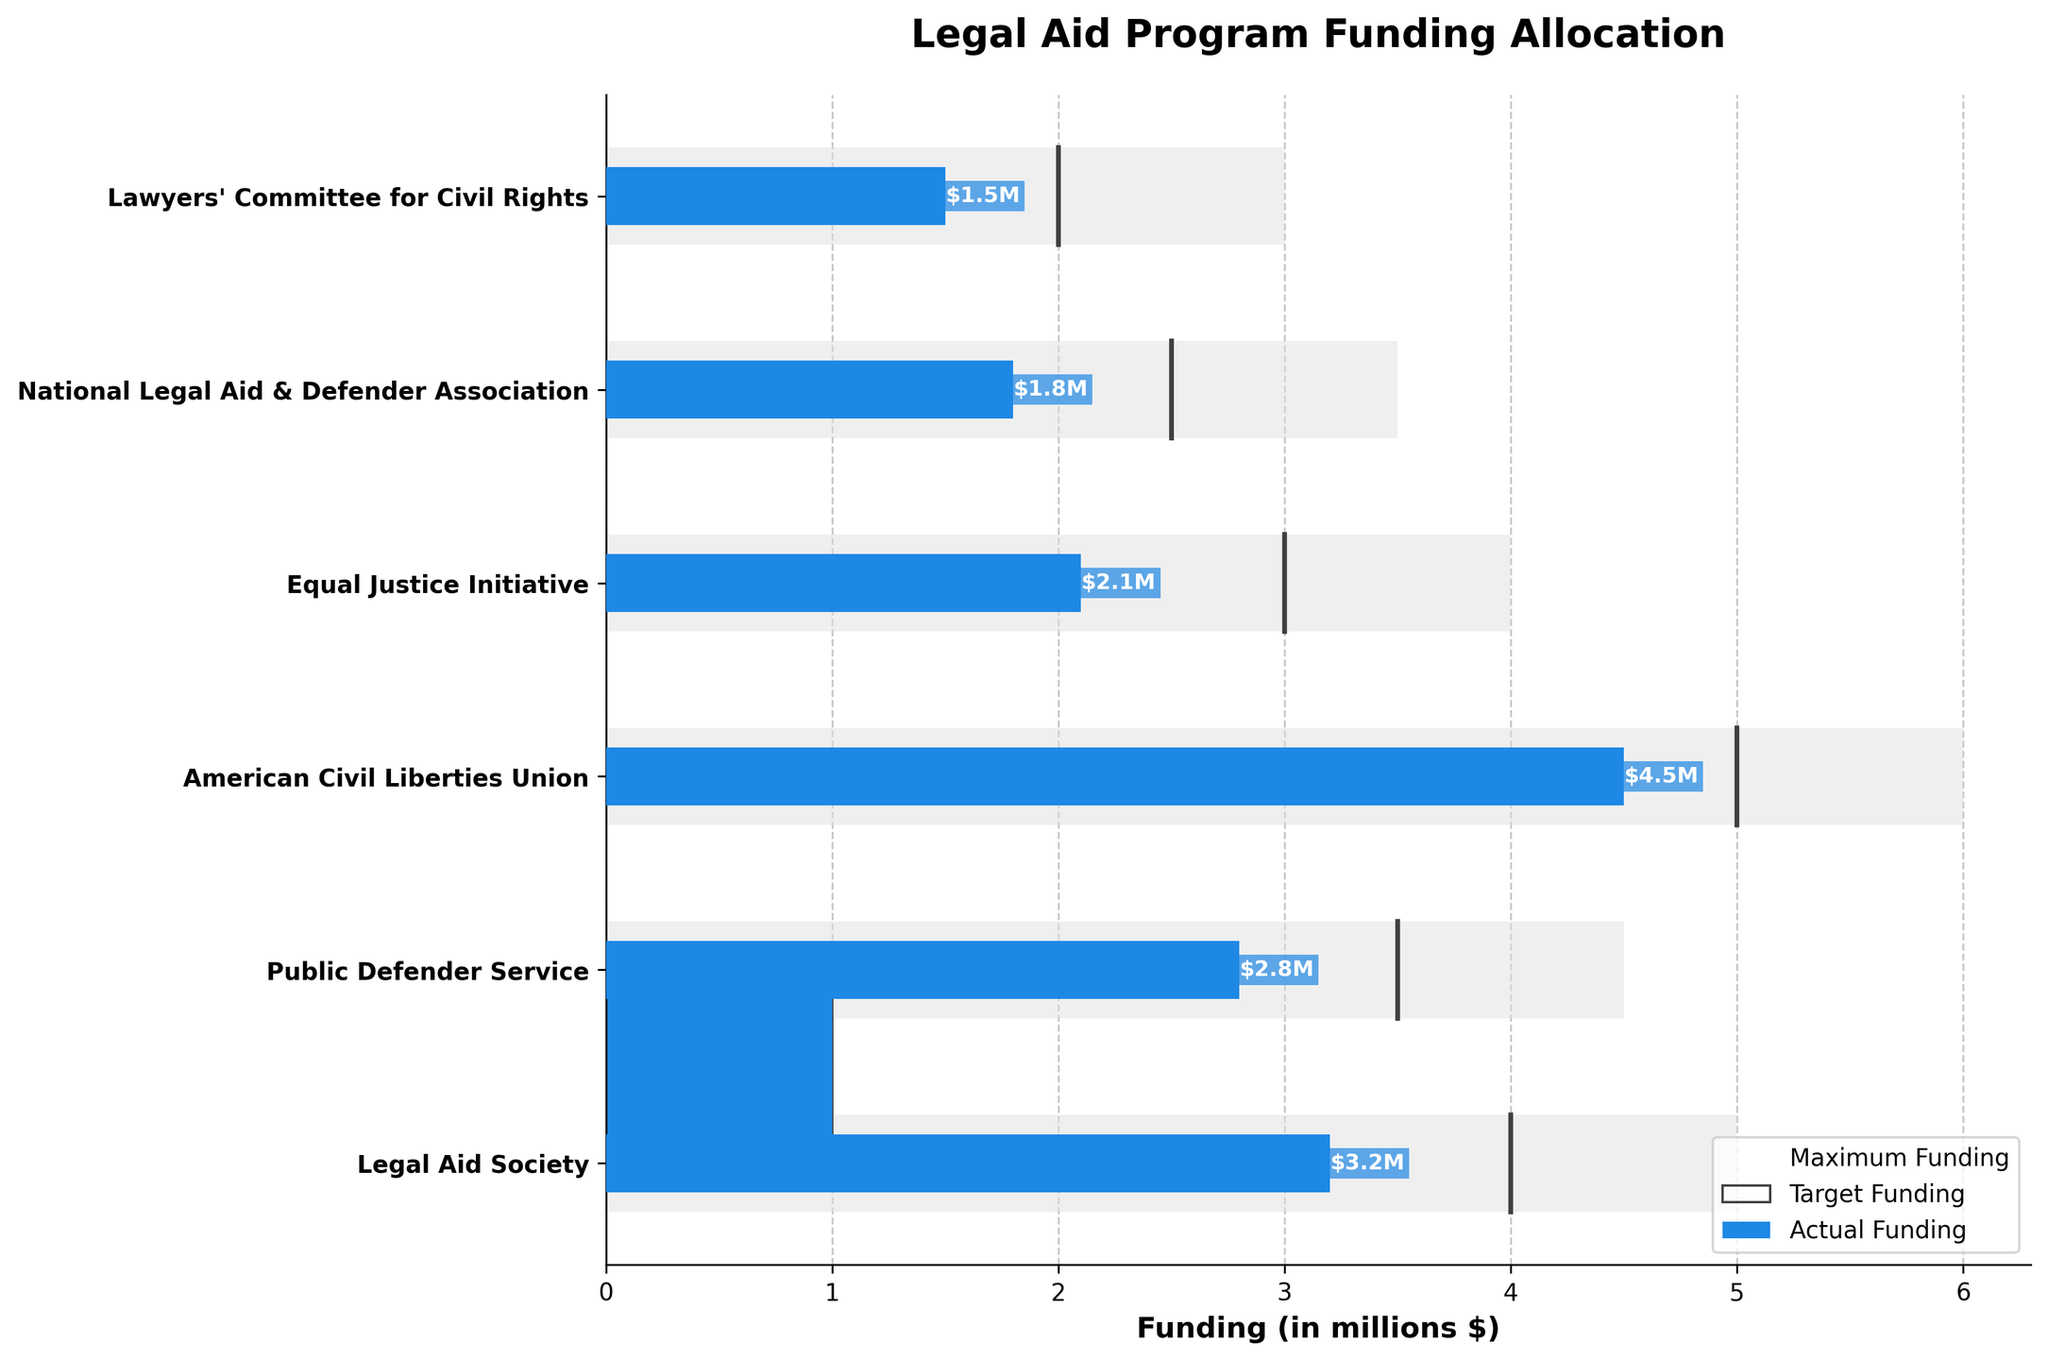What is the title of the chart? The title is displayed prominently at the top of the chart. It reads "Legal Aid Program Funding Allocation" which indicates the chart's subject matter.
Answer: Legal Aid Program Funding Allocation Which program received the highest actual funding? The bars representing actual funding are color-coded in blue. The longest blue bar corresponds to the "American Civil Liberties Union" program.
Answer: American Civil Liberties Union What is the target funding for the Lawyers' Committee for Civil Rights? Look for the mark representing target funding next to the "Lawyers' Committee for Civil Rights" label. It is marked by a thin black line, indicated at the $2.0M level on the x-axis.
Answer: $2.0M How much more funding does the Legal Aid Society need to reach its target? Subtract the actual funding from the target funding for the Legal Aid Society. The target is $4.0M and the actual is $3.2M. (4.0 - 3.2 = 0.8)
Answer: $0.8M Which program has the smallest gap between actual and maximum funding? Compare the differences between the actual and maximum funding for each program by examining the lengths of the bars and the grey background bars. The "American Civil Liberties Union" has the smallest difference with actual funding of $4.5M and maximum funding of $6.0M. (6.0 - 4.5 = 1.5)
Answer: American Civil Liberties Union How does the actual funding for the Equal Justice Initiative compare to its target? Compare the length of the blue bar (actual funding) with the thin black line (target funding) for the Equal Justice Initiative. The actual funding is $2.1M and the target is $3.0M. (2.1 < 3.0)
Answer: Less than its target What percentage of the maximum funding has the Public Defender Service received? Divide the actual funding by the maximum funding and multiply by 100 to get the percentage. For the Public Defender Service, this is (2.8 / 4.5) * 100 = 62.22%.
Answer: 62.22% Which programs have achieved their target funding? Check if the lengths of the blue bars (actual funding) are equal to the positions of the black lines (target funding). None of the programs have achieved their target funding in this chart.
Answer: None Compare the funding gap (target - actual) of the National Legal Aid & Defender Association and the Public Defender Service. Calculate the difference between target and actual funding for each program. National Legal Aid & Defender Association: (2.5 - 1.8 = 0.7M), Public Defender Service: (3.5 - 2.8 = 0.7M). They both have the same funding gap.
Answer: Equal (0.7M) How do the actual funding amounts for the Equal Justice Initiative and the Lawyers' Committee for Civil Rights compare? Look at the lengths of the blue bars for both programs. The actual funding for the Equal Justice Initiative is $2.1M and for the Lawyers' Committee for Civil Rights is $1.5M. (2.1 > 1.5)
Answer: Equal Justice Initiative has more 